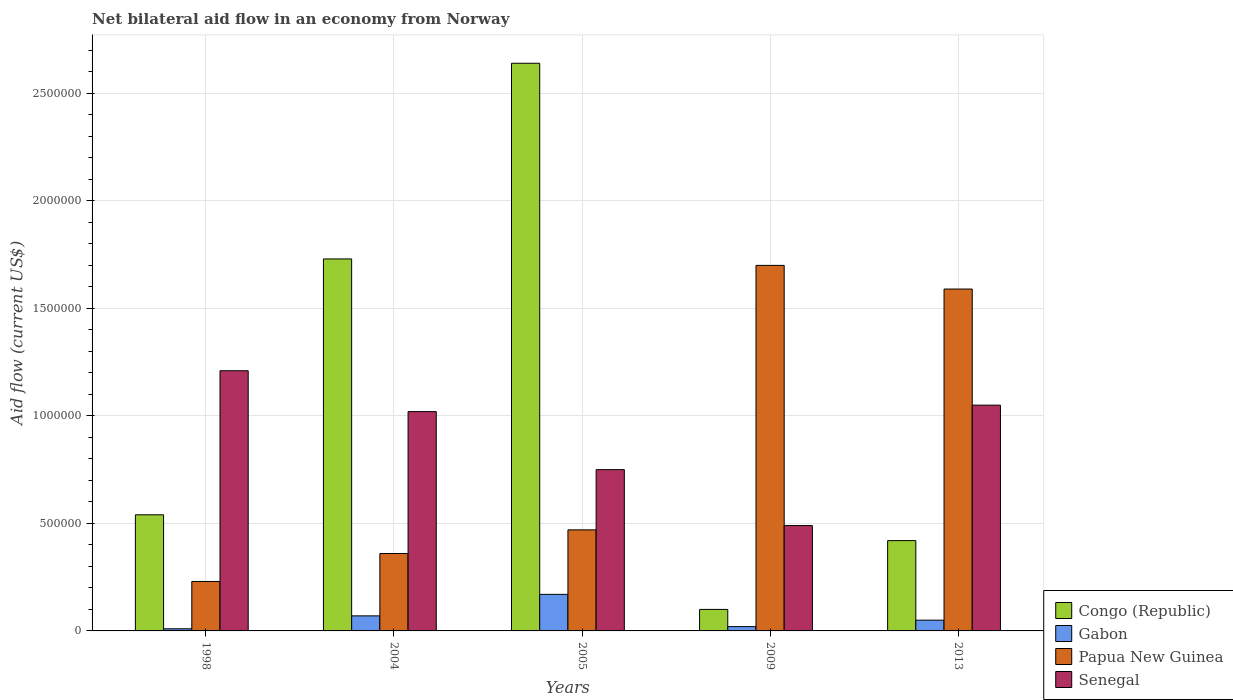Are the number of bars per tick equal to the number of legend labels?
Your answer should be very brief. Yes. Are the number of bars on each tick of the X-axis equal?
Make the answer very short. Yes. What is the label of the 3rd group of bars from the left?
Offer a terse response. 2005. In how many cases, is the number of bars for a given year not equal to the number of legend labels?
Ensure brevity in your answer.  0. What is the net bilateral aid flow in Congo (Republic) in 1998?
Ensure brevity in your answer.  5.40e+05. Across all years, what is the maximum net bilateral aid flow in Gabon?
Ensure brevity in your answer.  1.70e+05. In which year was the net bilateral aid flow in Papua New Guinea maximum?
Provide a succinct answer. 2009. What is the total net bilateral aid flow in Congo (Republic) in the graph?
Keep it short and to the point. 5.43e+06. What is the difference between the net bilateral aid flow in Papua New Guinea in 2004 and that in 2013?
Offer a terse response. -1.23e+06. What is the difference between the net bilateral aid flow in Gabon in 1998 and the net bilateral aid flow in Congo (Republic) in 2004?
Your answer should be very brief. -1.72e+06. What is the average net bilateral aid flow in Gabon per year?
Your answer should be compact. 6.40e+04. In the year 1998, what is the difference between the net bilateral aid flow in Senegal and net bilateral aid flow in Papua New Guinea?
Your answer should be very brief. 9.80e+05. In how many years, is the net bilateral aid flow in Gabon greater than 2000000 US$?
Ensure brevity in your answer.  0. What is the ratio of the net bilateral aid flow in Gabon in 1998 to that in 2004?
Provide a succinct answer. 0.14. Is the difference between the net bilateral aid flow in Senegal in 1998 and 2009 greater than the difference between the net bilateral aid flow in Papua New Guinea in 1998 and 2009?
Make the answer very short. Yes. What is the difference between the highest and the second highest net bilateral aid flow in Congo (Republic)?
Offer a very short reply. 9.10e+05. Is the sum of the net bilateral aid flow in Congo (Republic) in 2004 and 2013 greater than the maximum net bilateral aid flow in Papua New Guinea across all years?
Provide a short and direct response. Yes. Is it the case that in every year, the sum of the net bilateral aid flow in Gabon and net bilateral aid flow in Papua New Guinea is greater than the sum of net bilateral aid flow in Senegal and net bilateral aid flow in Congo (Republic)?
Provide a short and direct response. No. What does the 4th bar from the left in 2005 represents?
Give a very brief answer. Senegal. What does the 2nd bar from the right in 2004 represents?
Offer a terse response. Papua New Guinea. What is the difference between two consecutive major ticks on the Y-axis?
Give a very brief answer. 5.00e+05. Are the values on the major ticks of Y-axis written in scientific E-notation?
Your response must be concise. No. How many legend labels are there?
Your response must be concise. 4. What is the title of the graph?
Keep it short and to the point. Net bilateral aid flow in an economy from Norway. What is the Aid flow (current US$) of Congo (Republic) in 1998?
Provide a short and direct response. 5.40e+05. What is the Aid flow (current US$) of Gabon in 1998?
Your response must be concise. 10000. What is the Aid flow (current US$) of Papua New Guinea in 1998?
Ensure brevity in your answer.  2.30e+05. What is the Aid flow (current US$) of Senegal in 1998?
Your response must be concise. 1.21e+06. What is the Aid flow (current US$) of Congo (Republic) in 2004?
Make the answer very short. 1.73e+06. What is the Aid flow (current US$) of Papua New Guinea in 2004?
Provide a short and direct response. 3.60e+05. What is the Aid flow (current US$) of Senegal in 2004?
Your answer should be very brief. 1.02e+06. What is the Aid flow (current US$) of Congo (Republic) in 2005?
Provide a short and direct response. 2.64e+06. What is the Aid flow (current US$) in Gabon in 2005?
Offer a very short reply. 1.70e+05. What is the Aid flow (current US$) in Senegal in 2005?
Provide a short and direct response. 7.50e+05. What is the Aid flow (current US$) of Congo (Republic) in 2009?
Offer a very short reply. 1.00e+05. What is the Aid flow (current US$) in Papua New Guinea in 2009?
Give a very brief answer. 1.70e+06. What is the Aid flow (current US$) of Senegal in 2009?
Offer a terse response. 4.90e+05. What is the Aid flow (current US$) in Gabon in 2013?
Keep it short and to the point. 5.00e+04. What is the Aid flow (current US$) in Papua New Guinea in 2013?
Your answer should be very brief. 1.59e+06. What is the Aid flow (current US$) of Senegal in 2013?
Provide a succinct answer. 1.05e+06. Across all years, what is the maximum Aid flow (current US$) in Congo (Republic)?
Offer a very short reply. 2.64e+06. Across all years, what is the maximum Aid flow (current US$) in Papua New Guinea?
Your answer should be compact. 1.70e+06. Across all years, what is the maximum Aid flow (current US$) of Senegal?
Provide a succinct answer. 1.21e+06. Across all years, what is the minimum Aid flow (current US$) of Gabon?
Offer a very short reply. 10000. Across all years, what is the minimum Aid flow (current US$) of Senegal?
Your answer should be very brief. 4.90e+05. What is the total Aid flow (current US$) of Congo (Republic) in the graph?
Provide a short and direct response. 5.43e+06. What is the total Aid flow (current US$) in Gabon in the graph?
Give a very brief answer. 3.20e+05. What is the total Aid flow (current US$) in Papua New Guinea in the graph?
Offer a very short reply. 4.35e+06. What is the total Aid flow (current US$) of Senegal in the graph?
Offer a terse response. 4.52e+06. What is the difference between the Aid flow (current US$) of Congo (Republic) in 1998 and that in 2004?
Keep it short and to the point. -1.19e+06. What is the difference between the Aid flow (current US$) in Gabon in 1998 and that in 2004?
Ensure brevity in your answer.  -6.00e+04. What is the difference between the Aid flow (current US$) in Congo (Republic) in 1998 and that in 2005?
Your response must be concise. -2.10e+06. What is the difference between the Aid flow (current US$) of Gabon in 1998 and that in 2005?
Give a very brief answer. -1.60e+05. What is the difference between the Aid flow (current US$) in Papua New Guinea in 1998 and that in 2005?
Provide a succinct answer. -2.40e+05. What is the difference between the Aid flow (current US$) in Senegal in 1998 and that in 2005?
Keep it short and to the point. 4.60e+05. What is the difference between the Aid flow (current US$) of Congo (Republic) in 1998 and that in 2009?
Offer a terse response. 4.40e+05. What is the difference between the Aid flow (current US$) in Papua New Guinea in 1998 and that in 2009?
Make the answer very short. -1.47e+06. What is the difference between the Aid flow (current US$) of Senegal in 1998 and that in 2009?
Make the answer very short. 7.20e+05. What is the difference between the Aid flow (current US$) in Congo (Republic) in 1998 and that in 2013?
Provide a succinct answer. 1.20e+05. What is the difference between the Aid flow (current US$) in Papua New Guinea in 1998 and that in 2013?
Your answer should be very brief. -1.36e+06. What is the difference between the Aid flow (current US$) of Senegal in 1998 and that in 2013?
Offer a very short reply. 1.60e+05. What is the difference between the Aid flow (current US$) of Congo (Republic) in 2004 and that in 2005?
Your answer should be very brief. -9.10e+05. What is the difference between the Aid flow (current US$) of Papua New Guinea in 2004 and that in 2005?
Ensure brevity in your answer.  -1.10e+05. What is the difference between the Aid flow (current US$) in Congo (Republic) in 2004 and that in 2009?
Ensure brevity in your answer.  1.63e+06. What is the difference between the Aid flow (current US$) of Gabon in 2004 and that in 2009?
Ensure brevity in your answer.  5.00e+04. What is the difference between the Aid flow (current US$) in Papua New Guinea in 2004 and that in 2009?
Give a very brief answer. -1.34e+06. What is the difference between the Aid flow (current US$) in Senegal in 2004 and that in 2009?
Provide a succinct answer. 5.30e+05. What is the difference between the Aid flow (current US$) in Congo (Republic) in 2004 and that in 2013?
Your response must be concise. 1.31e+06. What is the difference between the Aid flow (current US$) of Papua New Guinea in 2004 and that in 2013?
Make the answer very short. -1.23e+06. What is the difference between the Aid flow (current US$) of Senegal in 2004 and that in 2013?
Provide a short and direct response. -3.00e+04. What is the difference between the Aid flow (current US$) in Congo (Republic) in 2005 and that in 2009?
Offer a terse response. 2.54e+06. What is the difference between the Aid flow (current US$) in Gabon in 2005 and that in 2009?
Your answer should be compact. 1.50e+05. What is the difference between the Aid flow (current US$) in Papua New Guinea in 2005 and that in 2009?
Your response must be concise. -1.23e+06. What is the difference between the Aid flow (current US$) in Senegal in 2005 and that in 2009?
Offer a very short reply. 2.60e+05. What is the difference between the Aid flow (current US$) of Congo (Republic) in 2005 and that in 2013?
Offer a terse response. 2.22e+06. What is the difference between the Aid flow (current US$) in Papua New Guinea in 2005 and that in 2013?
Make the answer very short. -1.12e+06. What is the difference between the Aid flow (current US$) of Congo (Republic) in 2009 and that in 2013?
Your response must be concise. -3.20e+05. What is the difference between the Aid flow (current US$) of Gabon in 2009 and that in 2013?
Ensure brevity in your answer.  -3.00e+04. What is the difference between the Aid flow (current US$) of Papua New Guinea in 2009 and that in 2013?
Your answer should be compact. 1.10e+05. What is the difference between the Aid flow (current US$) of Senegal in 2009 and that in 2013?
Make the answer very short. -5.60e+05. What is the difference between the Aid flow (current US$) of Congo (Republic) in 1998 and the Aid flow (current US$) of Gabon in 2004?
Your response must be concise. 4.70e+05. What is the difference between the Aid flow (current US$) of Congo (Republic) in 1998 and the Aid flow (current US$) of Papua New Guinea in 2004?
Offer a very short reply. 1.80e+05. What is the difference between the Aid flow (current US$) of Congo (Republic) in 1998 and the Aid flow (current US$) of Senegal in 2004?
Offer a terse response. -4.80e+05. What is the difference between the Aid flow (current US$) of Gabon in 1998 and the Aid flow (current US$) of Papua New Guinea in 2004?
Keep it short and to the point. -3.50e+05. What is the difference between the Aid flow (current US$) of Gabon in 1998 and the Aid flow (current US$) of Senegal in 2004?
Offer a very short reply. -1.01e+06. What is the difference between the Aid flow (current US$) in Papua New Guinea in 1998 and the Aid flow (current US$) in Senegal in 2004?
Offer a terse response. -7.90e+05. What is the difference between the Aid flow (current US$) in Congo (Republic) in 1998 and the Aid flow (current US$) in Papua New Guinea in 2005?
Offer a very short reply. 7.00e+04. What is the difference between the Aid flow (current US$) in Congo (Republic) in 1998 and the Aid flow (current US$) in Senegal in 2005?
Provide a short and direct response. -2.10e+05. What is the difference between the Aid flow (current US$) of Gabon in 1998 and the Aid flow (current US$) of Papua New Guinea in 2005?
Ensure brevity in your answer.  -4.60e+05. What is the difference between the Aid flow (current US$) in Gabon in 1998 and the Aid flow (current US$) in Senegal in 2005?
Give a very brief answer. -7.40e+05. What is the difference between the Aid flow (current US$) of Papua New Guinea in 1998 and the Aid flow (current US$) of Senegal in 2005?
Ensure brevity in your answer.  -5.20e+05. What is the difference between the Aid flow (current US$) of Congo (Republic) in 1998 and the Aid flow (current US$) of Gabon in 2009?
Give a very brief answer. 5.20e+05. What is the difference between the Aid flow (current US$) in Congo (Republic) in 1998 and the Aid flow (current US$) in Papua New Guinea in 2009?
Make the answer very short. -1.16e+06. What is the difference between the Aid flow (current US$) of Congo (Republic) in 1998 and the Aid flow (current US$) of Senegal in 2009?
Provide a succinct answer. 5.00e+04. What is the difference between the Aid flow (current US$) in Gabon in 1998 and the Aid flow (current US$) in Papua New Guinea in 2009?
Your answer should be compact. -1.69e+06. What is the difference between the Aid flow (current US$) in Gabon in 1998 and the Aid flow (current US$) in Senegal in 2009?
Give a very brief answer. -4.80e+05. What is the difference between the Aid flow (current US$) of Congo (Republic) in 1998 and the Aid flow (current US$) of Gabon in 2013?
Your answer should be very brief. 4.90e+05. What is the difference between the Aid flow (current US$) of Congo (Republic) in 1998 and the Aid flow (current US$) of Papua New Guinea in 2013?
Offer a very short reply. -1.05e+06. What is the difference between the Aid flow (current US$) in Congo (Republic) in 1998 and the Aid flow (current US$) in Senegal in 2013?
Make the answer very short. -5.10e+05. What is the difference between the Aid flow (current US$) of Gabon in 1998 and the Aid flow (current US$) of Papua New Guinea in 2013?
Make the answer very short. -1.58e+06. What is the difference between the Aid flow (current US$) in Gabon in 1998 and the Aid flow (current US$) in Senegal in 2013?
Your answer should be compact. -1.04e+06. What is the difference between the Aid flow (current US$) of Papua New Guinea in 1998 and the Aid flow (current US$) of Senegal in 2013?
Provide a succinct answer. -8.20e+05. What is the difference between the Aid flow (current US$) of Congo (Republic) in 2004 and the Aid flow (current US$) of Gabon in 2005?
Your response must be concise. 1.56e+06. What is the difference between the Aid flow (current US$) in Congo (Republic) in 2004 and the Aid flow (current US$) in Papua New Guinea in 2005?
Give a very brief answer. 1.26e+06. What is the difference between the Aid flow (current US$) of Congo (Republic) in 2004 and the Aid flow (current US$) of Senegal in 2005?
Ensure brevity in your answer.  9.80e+05. What is the difference between the Aid flow (current US$) in Gabon in 2004 and the Aid flow (current US$) in Papua New Guinea in 2005?
Your answer should be compact. -4.00e+05. What is the difference between the Aid flow (current US$) in Gabon in 2004 and the Aid flow (current US$) in Senegal in 2005?
Give a very brief answer. -6.80e+05. What is the difference between the Aid flow (current US$) of Papua New Guinea in 2004 and the Aid flow (current US$) of Senegal in 2005?
Offer a terse response. -3.90e+05. What is the difference between the Aid flow (current US$) in Congo (Republic) in 2004 and the Aid flow (current US$) in Gabon in 2009?
Offer a very short reply. 1.71e+06. What is the difference between the Aid flow (current US$) of Congo (Republic) in 2004 and the Aid flow (current US$) of Papua New Guinea in 2009?
Make the answer very short. 3.00e+04. What is the difference between the Aid flow (current US$) of Congo (Republic) in 2004 and the Aid flow (current US$) of Senegal in 2009?
Ensure brevity in your answer.  1.24e+06. What is the difference between the Aid flow (current US$) in Gabon in 2004 and the Aid flow (current US$) in Papua New Guinea in 2009?
Your answer should be compact. -1.63e+06. What is the difference between the Aid flow (current US$) of Gabon in 2004 and the Aid flow (current US$) of Senegal in 2009?
Ensure brevity in your answer.  -4.20e+05. What is the difference between the Aid flow (current US$) of Congo (Republic) in 2004 and the Aid flow (current US$) of Gabon in 2013?
Provide a short and direct response. 1.68e+06. What is the difference between the Aid flow (current US$) of Congo (Republic) in 2004 and the Aid flow (current US$) of Senegal in 2013?
Give a very brief answer. 6.80e+05. What is the difference between the Aid flow (current US$) of Gabon in 2004 and the Aid flow (current US$) of Papua New Guinea in 2013?
Provide a succinct answer. -1.52e+06. What is the difference between the Aid flow (current US$) in Gabon in 2004 and the Aid flow (current US$) in Senegal in 2013?
Keep it short and to the point. -9.80e+05. What is the difference between the Aid flow (current US$) of Papua New Guinea in 2004 and the Aid flow (current US$) of Senegal in 2013?
Ensure brevity in your answer.  -6.90e+05. What is the difference between the Aid flow (current US$) in Congo (Republic) in 2005 and the Aid flow (current US$) in Gabon in 2009?
Provide a short and direct response. 2.62e+06. What is the difference between the Aid flow (current US$) in Congo (Republic) in 2005 and the Aid flow (current US$) in Papua New Guinea in 2009?
Keep it short and to the point. 9.40e+05. What is the difference between the Aid flow (current US$) of Congo (Republic) in 2005 and the Aid flow (current US$) of Senegal in 2009?
Give a very brief answer. 2.15e+06. What is the difference between the Aid flow (current US$) in Gabon in 2005 and the Aid flow (current US$) in Papua New Guinea in 2009?
Give a very brief answer. -1.53e+06. What is the difference between the Aid flow (current US$) of Gabon in 2005 and the Aid flow (current US$) of Senegal in 2009?
Your answer should be very brief. -3.20e+05. What is the difference between the Aid flow (current US$) of Papua New Guinea in 2005 and the Aid flow (current US$) of Senegal in 2009?
Offer a very short reply. -2.00e+04. What is the difference between the Aid flow (current US$) in Congo (Republic) in 2005 and the Aid flow (current US$) in Gabon in 2013?
Make the answer very short. 2.59e+06. What is the difference between the Aid flow (current US$) of Congo (Republic) in 2005 and the Aid flow (current US$) of Papua New Guinea in 2013?
Provide a short and direct response. 1.05e+06. What is the difference between the Aid flow (current US$) in Congo (Republic) in 2005 and the Aid flow (current US$) in Senegal in 2013?
Make the answer very short. 1.59e+06. What is the difference between the Aid flow (current US$) in Gabon in 2005 and the Aid flow (current US$) in Papua New Guinea in 2013?
Your response must be concise. -1.42e+06. What is the difference between the Aid flow (current US$) of Gabon in 2005 and the Aid flow (current US$) of Senegal in 2013?
Offer a very short reply. -8.80e+05. What is the difference between the Aid flow (current US$) in Papua New Guinea in 2005 and the Aid flow (current US$) in Senegal in 2013?
Offer a terse response. -5.80e+05. What is the difference between the Aid flow (current US$) of Congo (Republic) in 2009 and the Aid flow (current US$) of Gabon in 2013?
Offer a terse response. 5.00e+04. What is the difference between the Aid flow (current US$) in Congo (Republic) in 2009 and the Aid flow (current US$) in Papua New Guinea in 2013?
Ensure brevity in your answer.  -1.49e+06. What is the difference between the Aid flow (current US$) of Congo (Republic) in 2009 and the Aid flow (current US$) of Senegal in 2013?
Provide a short and direct response. -9.50e+05. What is the difference between the Aid flow (current US$) in Gabon in 2009 and the Aid flow (current US$) in Papua New Guinea in 2013?
Offer a terse response. -1.57e+06. What is the difference between the Aid flow (current US$) of Gabon in 2009 and the Aid flow (current US$) of Senegal in 2013?
Offer a terse response. -1.03e+06. What is the difference between the Aid flow (current US$) in Papua New Guinea in 2009 and the Aid flow (current US$) in Senegal in 2013?
Provide a succinct answer. 6.50e+05. What is the average Aid flow (current US$) of Congo (Republic) per year?
Your response must be concise. 1.09e+06. What is the average Aid flow (current US$) of Gabon per year?
Provide a short and direct response. 6.40e+04. What is the average Aid flow (current US$) of Papua New Guinea per year?
Offer a very short reply. 8.70e+05. What is the average Aid flow (current US$) of Senegal per year?
Give a very brief answer. 9.04e+05. In the year 1998, what is the difference between the Aid flow (current US$) in Congo (Republic) and Aid flow (current US$) in Gabon?
Your answer should be compact. 5.30e+05. In the year 1998, what is the difference between the Aid flow (current US$) of Congo (Republic) and Aid flow (current US$) of Senegal?
Keep it short and to the point. -6.70e+05. In the year 1998, what is the difference between the Aid flow (current US$) in Gabon and Aid flow (current US$) in Papua New Guinea?
Keep it short and to the point. -2.20e+05. In the year 1998, what is the difference between the Aid flow (current US$) in Gabon and Aid flow (current US$) in Senegal?
Your answer should be compact. -1.20e+06. In the year 1998, what is the difference between the Aid flow (current US$) in Papua New Guinea and Aid flow (current US$) in Senegal?
Keep it short and to the point. -9.80e+05. In the year 2004, what is the difference between the Aid flow (current US$) of Congo (Republic) and Aid flow (current US$) of Gabon?
Keep it short and to the point. 1.66e+06. In the year 2004, what is the difference between the Aid flow (current US$) in Congo (Republic) and Aid flow (current US$) in Papua New Guinea?
Ensure brevity in your answer.  1.37e+06. In the year 2004, what is the difference between the Aid flow (current US$) in Congo (Republic) and Aid flow (current US$) in Senegal?
Your answer should be very brief. 7.10e+05. In the year 2004, what is the difference between the Aid flow (current US$) in Gabon and Aid flow (current US$) in Papua New Guinea?
Keep it short and to the point. -2.90e+05. In the year 2004, what is the difference between the Aid flow (current US$) of Gabon and Aid flow (current US$) of Senegal?
Offer a terse response. -9.50e+05. In the year 2004, what is the difference between the Aid flow (current US$) of Papua New Guinea and Aid flow (current US$) of Senegal?
Your response must be concise. -6.60e+05. In the year 2005, what is the difference between the Aid flow (current US$) in Congo (Republic) and Aid flow (current US$) in Gabon?
Ensure brevity in your answer.  2.47e+06. In the year 2005, what is the difference between the Aid flow (current US$) of Congo (Republic) and Aid flow (current US$) of Papua New Guinea?
Make the answer very short. 2.17e+06. In the year 2005, what is the difference between the Aid flow (current US$) of Congo (Republic) and Aid flow (current US$) of Senegal?
Offer a very short reply. 1.89e+06. In the year 2005, what is the difference between the Aid flow (current US$) in Gabon and Aid flow (current US$) in Senegal?
Keep it short and to the point. -5.80e+05. In the year 2005, what is the difference between the Aid flow (current US$) in Papua New Guinea and Aid flow (current US$) in Senegal?
Offer a very short reply. -2.80e+05. In the year 2009, what is the difference between the Aid flow (current US$) of Congo (Republic) and Aid flow (current US$) of Gabon?
Provide a short and direct response. 8.00e+04. In the year 2009, what is the difference between the Aid flow (current US$) in Congo (Republic) and Aid flow (current US$) in Papua New Guinea?
Provide a succinct answer. -1.60e+06. In the year 2009, what is the difference between the Aid flow (current US$) of Congo (Republic) and Aid flow (current US$) of Senegal?
Offer a terse response. -3.90e+05. In the year 2009, what is the difference between the Aid flow (current US$) in Gabon and Aid flow (current US$) in Papua New Guinea?
Your response must be concise. -1.68e+06. In the year 2009, what is the difference between the Aid flow (current US$) of Gabon and Aid flow (current US$) of Senegal?
Offer a very short reply. -4.70e+05. In the year 2009, what is the difference between the Aid flow (current US$) in Papua New Guinea and Aid flow (current US$) in Senegal?
Provide a short and direct response. 1.21e+06. In the year 2013, what is the difference between the Aid flow (current US$) of Congo (Republic) and Aid flow (current US$) of Gabon?
Your response must be concise. 3.70e+05. In the year 2013, what is the difference between the Aid flow (current US$) in Congo (Republic) and Aid flow (current US$) in Papua New Guinea?
Your answer should be very brief. -1.17e+06. In the year 2013, what is the difference between the Aid flow (current US$) in Congo (Republic) and Aid flow (current US$) in Senegal?
Offer a very short reply. -6.30e+05. In the year 2013, what is the difference between the Aid flow (current US$) of Gabon and Aid flow (current US$) of Papua New Guinea?
Provide a succinct answer. -1.54e+06. In the year 2013, what is the difference between the Aid flow (current US$) of Gabon and Aid flow (current US$) of Senegal?
Offer a terse response. -1.00e+06. In the year 2013, what is the difference between the Aid flow (current US$) in Papua New Guinea and Aid flow (current US$) in Senegal?
Offer a very short reply. 5.40e+05. What is the ratio of the Aid flow (current US$) of Congo (Republic) in 1998 to that in 2004?
Your answer should be compact. 0.31. What is the ratio of the Aid flow (current US$) of Gabon in 1998 to that in 2004?
Provide a succinct answer. 0.14. What is the ratio of the Aid flow (current US$) in Papua New Guinea in 1998 to that in 2004?
Keep it short and to the point. 0.64. What is the ratio of the Aid flow (current US$) of Senegal in 1998 to that in 2004?
Provide a succinct answer. 1.19. What is the ratio of the Aid flow (current US$) of Congo (Republic) in 1998 to that in 2005?
Provide a succinct answer. 0.2. What is the ratio of the Aid flow (current US$) in Gabon in 1998 to that in 2005?
Your answer should be very brief. 0.06. What is the ratio of the Aid flow (current US$) of Papua New Guinea in 1998 to that in 2005?
Your answer should be very brief. 0.49. What is the ratio of the Aid flow (current US$) of Senegal in 1998 to that in 2005?
Your answer should be very brief. 1.61. What is the ratio of the Aid flow (current US$) in Papua New Guinea in 1998 to that in 2009?
Provide a succinct answer. 0.14. What is the ratio of the Aid flow (current US$) in Senegal in 1998 to that in 2009?
Provide a short and direct response. 2.47. What is the ratio of the Aid flow (current US$) in Papua New Guinea in 1998 to that in 2013?
Your answer should be compact. 0.14. What is the ratio of the Aid flow (current US$) of Senegal in 1998 to that in 2013?
Your response must be concise. 1.15. What is the ratio of the Aid flow (current US$) in Congo (Republic) in 2004 to that in 2005?
Keep it short and to the point. 0.66. What is the ratio of the Aid flow (current US$) in Gabon in 2004 to that in 2005?
Your answer should be very brief. 0.41. What is the ratio of the Aid flow (current US$) in Papua New Guinea in 2004 to that in 2005?
Provide a short and direct response. 0.77. What is the ratio of the Aid flow (current US$) in Senegal in 2004 to that in 2005?
Your answer should be compact. 1.36. What is the ratio of the Aid flow (current US$) in Gabon in 2004 to that in 2009?
Your answer should be compact. 3.5. What is the ratio of the Aid flow (current US$) in Papua New Guinea in 2004 to that in 2009?
Offer a terse response. 0.21. What is the ratio of the Aid flow (current US$) of Senegal in 2004 to that in 2009?
Provide a succinct answer. 2.08. What is the ratio of the Aid flow (current US$) of Congo (Republic) in 2004 to that in 2013?
Make the answer very short. 4.12. What is the ratio of the Aid flow (current US$) of Papua New Guinea in 2004 to that in 2013?
Keep it short and to the point. 0.23. What is the ratio of the Aid flow (current US$) in Senegal in 2004 to that in 2013?
Provide a succinct answer. 0.97. What is the ratio of the Aid flow (current US$) of Congo (Republic) in 2005 to that in 2009?
Give a very brief answer. 26.4. What is the ratio of the Aid flow (current US$) in Papua New Guinea in 2005 to that in 2009?
Keep it short and to the point. 0.28. What is the ratio of the Aid flow (current US$) in Senegal in 2005 to that in 2009?
Give a very brief answer. 1.53. What is the ratio of the Aid flow (current US$) in Congo (Republic) in 2005 to that in 2013?
Keep it short and to the point. 6.29. What is the ratio of the Aid flow (current US$) of Gabon in 2005 to that in 2013?
Keep it short and to the point. 3.4. What is the ratio of the Aid flow (current US$) of Papua New Guinea in 2005 to that in 2013?
Your answer should be compact. 0.3. What is the ratio of the Aid flow (current US$) of Congo (Republic) in 2009 to that in 2013?
Ensure brevity in your answer.  0.24. What is the ratio of the Aid flow (current US$) in Gabon in 2009 to that in 2013?
Offer a very short reply. 0.4. What is the ratio of the Aid flow (current US$) of Papua New Guinea in 2009 to that in 2013?
Keep it short and to the point. 1.07. What is the ratio of the Aid flow (current US$) in Senegal in 2009 to that in 2013?
Your response must be concise. 0.47. What is the difference between the highest and the second highest Aid flow (current US$) of Congo (Republic)?
Your answer should be very brief. 9.10e+05. What is the difference between the highest and the lowest Aid flow (current US$) of Congo (Republic)?
Offer a terse response. 2.54e+06. What is the difference between the highest and the lowest Aid flow (current US$) of Gabon?
Give a very brief answer. 1.60e+05. What is the difference between the highest and the lowest Aid flow (current US$) of Papua New Guinea?
Your response must be concise. 1.47e+06. What is the difference between the highest and the lowest Aid flow (current US$) of Senegal?
Your answer should be very brief. 7.20e+05. 